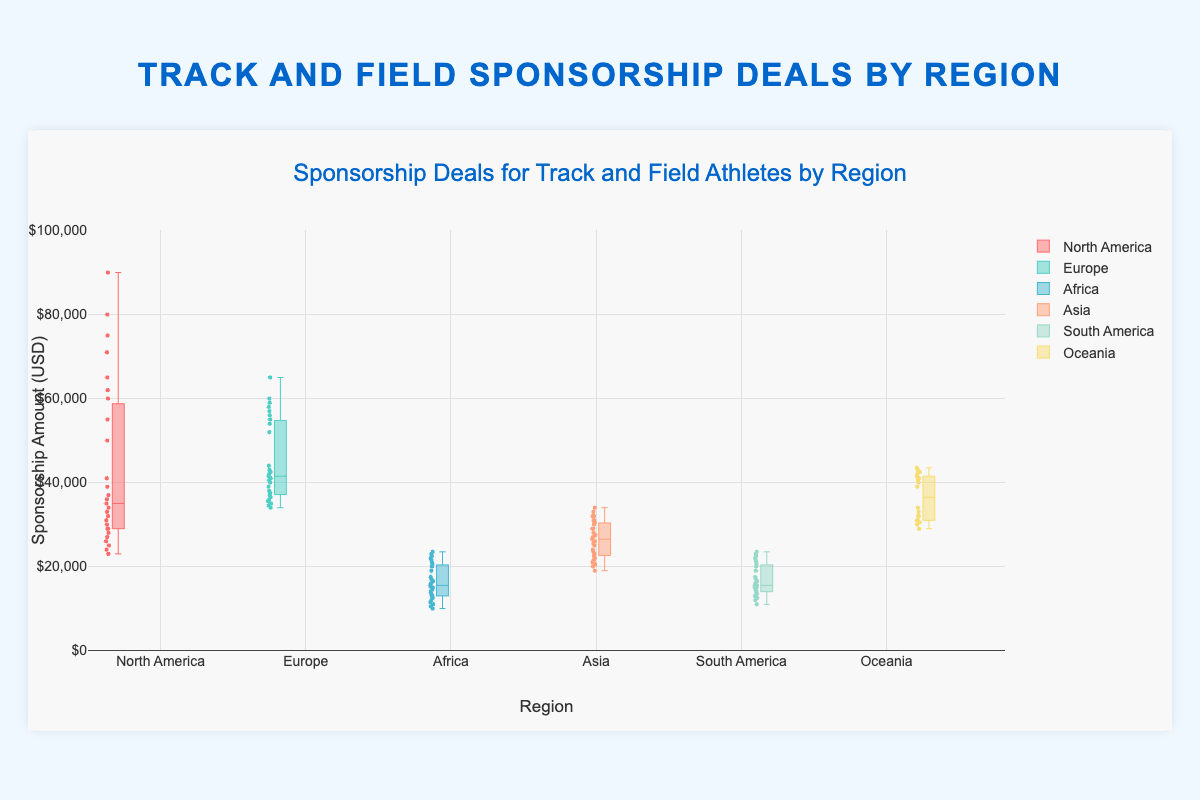Which region has the highest median sponsorship deal? Looking at the box plot, the median is indicated by the line inside each box. By comparing these lines, we can see that North America's median is highest.
Answer: North America Which country has the widest range of sponsorship deals in North America? The range is represented by the distance between the minimum and maximum values of the whiskers. For North America, the USA has the widest range as its whiskers span from 50,000 to 90,000, which is the largest range among the countries in this region.
Answer: USA How does the sponsorship amount for athletes from Africa compare to those from Oceania? By examining the height and position of the boxes, we can see the overall range and median values for Africa and Oceania. Africa has lower sponsorship amounts compared to Oceania, with median and highest values significantly lower in Africa.
Answer: Oceania has higher sponsorships Which region has the most evenly distributed sponsorship deals based on the box plot? Even distribution can be inferred from the spread and symmetry of the boxes and whiskers. Europe’s box plot appears more evenly spread without extreme outliers and a symmetric appearance around the median line.
Answer: Europe What is the average range of sponsorship deals for athletes in Asia? Calculating the range for each country in Asia (Japan: 40,000 - 29,000 = 10,000, China: 29,000 - 24,000 = 5,000, India: 23,500 - 19,000 = 4,500), and finding the average. (10,000 + 5,000 + 4,500) / 3 = 6,500
Answer: 6,500 Which country in South America has the lowest median sponsorship deal, and what is it? By examining the line inside each box for South American countries, Jamaica has the lowest median. From the box plot, it's around 13,500.
Answer: Jamaica, 13,500 Does any region have regions that overlap in sponsorship amounts? By inspecting the box plots closely, we can see that sponsorship amounts of several regions overlap. For instance, Africa and South America have overlapping ranges.
Answer: Yes What’s the median sponsorship amount for track and field athletes in Europe? By checking the median lines inside the boxes for European countries: UK (57,000, 52,500, 60,000), Germany (42,500), France (35,500), we average these medians. (57,000+42,500+35,500) /3 = 45,000
Answer: 45,000 Which region has the smallest variance in sponsorship deals? Small variance can be judged by the compactness of the box and whiskers. Asia, especially India, shows the smallest variance with all values close together.
Answer: Asia 